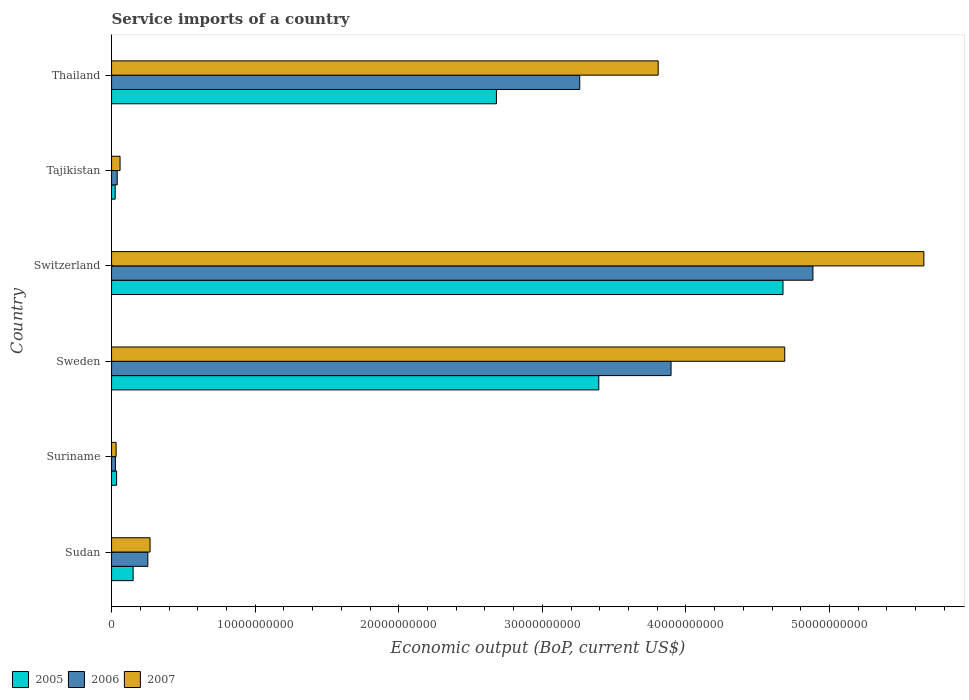Are the number of bars per tick equal to the number of legend labels?
Make the answer very short. Yes. How many bars are there on the 2nd tick from the bottom?
Make the answer very short. 3. What is the service imports in 2006 in Sweden?
Offer a terse response. 3.90e+1. Across all countries, what is the maximum service imports in 2007?
Your answer should be very brief. 5.66e+1. Across all countries, what is the minimum service imports in 2005?
Provide a short and direct response. 2.52e+08. In which country was the service imports in 2007 maximum?
Offer a terse response. Switzerland. In which country was the service imports in 2007 minimum?
Keep it short and to the point. Suriname. What is the total service imports in 2006 in the graph?
Give a very brief answer. 1.24e+11. What is the difference between the service imports in 2006 in Suriname and that in Thailand?
Make the answer very short. -3.23e+1. What is the difference between the service imports in 2006 in Sudan and the service imports in 2005 in Sweden?
Keep it short and to the point. -3.14e+1. What is the average service imports in 2006 per country?
Your answer should be very brief. 2.06e+1. What is the difference between the service imports in 2006 and service imports in 2007 in Sweden?
Ensure brevity in your answer.  -7.92e+09. What is the ratio of the service imports in 2006 in Sudan to that in Sweden?
Provide a succinct answer. 0.06. What is the difference between the highest and the second highest service imports in 2006?
Give a very brief answer. 9.88e+09. What is the difference between the highest and the lowest service imports in 2007?
Make the answer very short. 5.63e+1. Is the sum of the service imports in 2005 in Suriname and Tajikistan greater than the maximum service imports in 2006 across all countries?
Your answer should be compact. No. What does the 3rd bar from the bottom in Sudan represents?
Give a very brief answer. 2007. Is it the case that in every country, the sum of the service imports in 2005 and service imports in 2006 is greater than the service imports in 2007?
Make the answer very short. Yes. Are all the bars in the graph horizontal?
Offer a very short reply. Yes. How many countries are there in the graph?
Your answer should be very brief. 6. Does the graph contain any zero values?
Your answer should be compact. No. Where does the legend appear in the graph?
Your answer should be compact. Bottom left. How many legend labels are there?
Your answer should be very brief. 3. What is the title of the graph?
Your answer should be very brief. Service imports of a country. What is the label or title of the X-axis?
Your answer should be compact. Economic output (BoP, current US$). What is the Economic output (BoP, current US$) in 2005 in Sudan?
Make the answer very short. 1.50e+09. What is the Economic output (BoP, current US$) in 2006 in Sudan?
Your answer should be very brief. 2.53e+09. What is the Economic output (BoP, current US$) of 2007 in Sudan?
Ensure brevity in your answer.  2.68e+09. What is the Economic output (BoP, current US$) of 2005 in Suriname?
Provide a short and direct response. 3.52e+08. What is the Economic output (BoP, current US$) of 2006 in Suriname?
Offer a very short reply. 2.69e+08. What is the Economic output (BoP, current US$) in 2007 in Suriname?
Your response must be concise. 3.18e+08. What is the Economic output (BoP, current US$) of 2005 in Sweden?
Give a very brief answer. 3.39e+1. What is the Economic output (BoP, current US$) in 2006 in Sweden?
Offer a terse response. 3.90e+1. What is the Economic output (BoP, current US$) of 2007 in Sweden?
Your response must be concise. 4.69e+1. What is the Economic output (BoP, current US$) of 2005 in Switzerland?
Offer a terse response. 4.68e+1. What is the Economic output (BoP, current US$) in 2006 in Switzerland?
Offer a terse response. 4.88e+1. What is the Economic output (BoP, current US$) in 2007 in Switzerland?
Make the answer very short. 5.66e+1. What is the Economic output (BoP, current US$) in 2005 in Tajikistan?
Provide a short and direct response. 2.52e+08. What is the Economic output (BoP, current US$) in 2006 in Tajikistan?
Your response must be concise. 3.94e+08. What is the Economic output (BoP, current US$) of 2007 in Tajikistan?
Offer a terse response. 5.92e+08. What is the Economic output (BoP, current US$) of 2005 in Thailand?
Your response must be concise. 2.68e+1. What is the Economic output (BoP, current US$) of 2006 in Thailand?
Ensure brevity in your answer.  3.26e+1. What is the Economic output (BoP, current US$) in 2007 in Thailand?
Keep it short and to the point. 3.81e+1. Across all countries, what is the maximum Economic output (BoP, current US$) in 2005?
Give a very brief answer. 4.68e+1. Across all countries, what is the maximum Economic output (BoP, current US$) of 2006?
Provide a succinct answer. 4.88e+1. Across all countries, what is the maximum Economic output (BoP, current US$) in 2007?
Keep it short and to the point. 5.66e+1. Across all countries, what is the minimum Economic output (BoP, current US$) of 2005?
Your answer should be very brief. 2.52e+08. Across all countries, what is the minimum Economic output (BoP, current US$) of 2006?
Offer a terse response. 2.69e+08. Across all countries, what is the minimum Economic output (BoP, current US$) of 2007?
Ensure brevity in your answer.  3.18e+08. What is the total Economic output (BoP, current US$) of 2005 in the graph?
Provide a short and direct response. 1.10e+11. What is the total Economic output (BoP, current US$) in 2006 in the graph?
Offer a terse response. 1.24e+11. What is the total Economic output (BoP, current US$) of 2007 in the graph?
Offer a very short reply. 1.45e+11. What is the difference between the Economic output (BoP, current US$) in 2005 in Sudan and that in Suriname?
Give a very brief answer. 1.15e+09. What is the difference between the Economic output (BoP, current US$) in 2006 in Sudan and that in Suriname?
Your response must be concise. 2.26e+09. What is the difference between the Economic output (BoP, current US$) of 2007 in Sudan and that in Suriname?
Keep it short and to the point. 2.36e+09. What is the difference between the Economic output (BoP, current US$) in 2005 in Sudan and that in Sweden?
Make the answer very short. -3.24e+1. What is the difference between the Economic output (BoP, current US$) in 2006 in Sudan and that in Sweden?
Make the answer very short. -3.64e+1. What is the difference between the Economic output (BoP, current US$) of 2007 in Sudan and that in Sweden?
Keep it short and to the point. -4.42e+1. What is the difference between the Economic output (BoP, current US$) of 2005 in Sudan and that in Switzerland?
Ensure brevity in your answer.  -4.53e+1. What is the difference between the Economic output (BoP, current US$) of 2006 in Sudan and that in Switzerland?
Keep it short and to the point. -4.63e+1. What is the difference between the Economic output (BoP, current US$) in 2007 in Sudan and that in Switzerland?
Offer a very short reply. -5.39e+1. What is the difference between the Economic output (BoP, current US$) in 2005 in Sudan and that in Tajikistan?
Your response must be concise. 1.25e+09. What is the difference between the Economic output (BoP, current US$) in 2006 in Sudan and that in Tajikistan?
Give a very brief answer. 2.13e+09. What is the difference between the Economic output (BoP, current US$) of 2007 in Sudan and that in Tajikistan?
Offer a very short reply. 2.09e+09. What is the difference between the Economic output (BoP, current US$) of 2005 in Sudan and that in Thailand?
Your answer should be very brief. -2.53e+1. What is the difference between the Economic output (BoP, current US$) of 2006 in Sudan and that in Thailand?
Offer a very short reply. -3.01e+1. What is the difference between the Economic output (BoP, current US$) in 2007 in Sudan and that in Thailand?
Ensure brevity in your answer.  -3.54e+1. What is the difference between the Economic output (BoP, current US$) in 2005 in Suriname and that in Sweden?
Your answer should be compact. -3.36e+1. What is the difference between the Economic output (BoP, current US$) in 2006 in Suriname and that in Sweden?
Give a very brief answer. -3.87e+1. What is the difference between the Economic output (BoP, current US$) of 2007 in Suriname and that in Sweden?
Keep it short and to the point. -4.66e+1. What is the difference between the Economic output (BoP, current US$) of 2005 in Suriname and that in Switzerland?
Your response must be concise. -4.64e+1. What is the difference between the Economic output (BoP, current US$) in 2006 in Suriname and that in Switzerland?
Provide a short and direct response. -4.86e+1. What is the difference between the Economic output (BoP, current US$) of 2007 in Suriname and that in Switzerland?
Ensure brevity in your answer.  -5.63e+1. What is the difference between the Economic output (BoP, current US$) in 2005 in Suriname and that in Tajikistan?
Offer a terse response. 1.00e+08. What is the difference between the Economic output (BoP, current US$) of 2006 in Suriname and that in Tajikistan?
Offer a very short reply. -1.25e+08. What is the difference between the Economic output (BoP, current US$) in 2007 in Suriname and that in Tajikistan?
Offer a very short reply. -2.74e+08. What is the difference between the Economic output (BoP, current US$) in 2005 in Suriname and that in Thailand?
Keep it short and to the point. -2.65e+1. What is the difference between the Economic output (BoP, current US$) in 2006 in Suriname and that in Thailand?
Your answer should be very brief. -3.23e+1. What is the difference between the Economic output (BoP, current US$) of 2007 in Suriname and that in Thailand?
Provide a short and direct response. -3.77e+1. What is the difference between the Economic output (BoP, current US$) of 2005 in Sweden and that in Switzerland?
Your answer should be compact. -1.28e+1. What is the difference between the Economic output (BoP, current US$) in 2006 in Sweden and that in Switzerland?
Make the answer very short. -9.88e+09. What is the difference between the Economic output (BoP, current US$) of 2007 in Sweden and that in Switzerland?
Ensure brevity in your answer.  -9.69e+09. What is the difference between the Economic output (BoP, current US$) of 2005 in Sweden and that in Tajikistan?
Provide a short and direct response. 3.37e+1. What is the difference between the Economic output (BoP, current US$) in 2006 in Sweden and that in Tajikistan?
Your answer should be very brief. 3.86e+1. What is the difference between the Economic output (BoP, current US$) of 2007 in Sweden and that in Tajikistan?
Your answer should be very brief. 4.63e+1. What is the difference between the Economic output (BoP, current US$) of 2005 in Sweden and that in Thailand?
Provide a short and direct response. 7.13e+09. What is the difference between the Economic output (BoP, current US$) in 2006 in Sweden and that in Thailand?
Offer a terse response. 6.36e+09. What is the difference between the Economic output (BoP, current US$) in 2007 in Sweden and that in Thailand?
Your answer should be very brief. 8.81e+09. What is the difference between the Economic output (BoP, current US$) in 2005 in Switzerland and that in Tajikistan?
Make the answer very short. 4.65e+1. What is the difference between the Economic output (BoP, current US$) in 2006 in Switzerland and that in Tajikistan?
Make the answer very short. 4.84e+1. What is the difference between the Economic output (BoP, current US$) in 2007 in Switzerland and that in Tajikistan?
Your answer should be compact. 5.60e+1. What is the difference between the Economic output (BoP, current US$) in 2005 in Switzerland and that in Thailand?
Provide a succinct answer. 2.00e+1. What is the difference between the Economic output (BoP, current US$) of 2006 in Switzerland and that in Thailand?
Provide a succinct answer. 1.62e+1. What is the difference between the Economic output (BoP, current US$) in 2007 in Switzerland and that in Thailand?
Keep it short and to the point. 1.85e+1. What is the difference between the Economic output (BoP, current US$) in 2005 in Tajikistan and that in Thailand?
Provide a succinct answer. -2.66e+1. What is the difference between the Economic output (BoP, current US$) of 2006 in Tajikistan and that in Thailand?
Make the answer very short. -3.22e+1. What is the difference between the Economic output (BoP, current US$) of 2007 in Tajikistan and that in Thailand?
Provide a short and direct response. -3.75e+1. What is the difference between the Economic output (BoP, current US$) in 2005 in Sudan and the Economic output (BoP, current US$) in 2006 in Suriname?
Offer a very short reply. 1.23e+09. What is the difference between the Economic output (BoP, current US$) in 2005 in Sudan and the Economic output (BoP, current US$) in 2007 in Suriname?
Offer a terse response. 1.19e+09. What is the difference between the Economic output (BoP, current US$) of 2006 in Sudan and the Economic output (BoP, current US$) of 2007 in Suriname?
Make the answer very short. 2.21e+09. What is the difference between the Economic output (BoP, current US$) in 2005 in Sudan and the Economic output (BoP, current US$) in 2006 in Sweden?
Make the answer very short. -3.75e+1. What is the difference between the Economic output (BoP, current US$) in 2005 in Sudan and the Economic output (BoP, current US$) in 2007 in Sweden?
Ensure brevity in your answer.  -4.54e+1. What is the difference between the Economic output (BoP, current US$) in 2006 in Sudan and the Economic output (BoP, current US$) in 2007 in Sweden?
Keep it short and to the point. -4.44e+1. What is the difference between the Economic output (BoP, current US$) of 2005 in Sudan and the Economic output (BoP, current US$) of 2006 in Switzerland?
Your answer should be very brief. -4.73e+1. What is the difference between the Economic output (BoP, current US$) of 2005 in Sudan and the Economic output (BoP, current US$) of 2007 in Switzerland?
Provide a short and direct response. -5.51e+1. What is the difference between the Economic output (BoP, current US$) in 2006 in Sudan and the Economic output (BoP, current US$) in 2007 in Switzerland?
Your answer should be compact. -5.40e+1. What is the difference between the Economic output (BoP, current US$) in 2005 in Sudan and the Economic output (BoP, current US$) in 2006 in Tajikistan?
Provide a short and direct response. 1.11e+09. What is the difference between the Economic output (BoP, current US$) in 2005 in Sudan and the Economic output (BoP, current US$) in 2007 in Tajikistan?
Give a very brief answer. 9.11e+08. What is the difference between the Economic output (BoP, current US$) in 2006 in Sudan and the Economic output (BoP, current US$) in 2007 in Tajikistan?
Provide a short and direct response. 1.93e+09. What is the difference between the Economic output (BoP, current US$) of 2005 in Sudan and the Economic output (BoP, current US$) of 2006 in Thailand?
Offer a very short reply. -3.11e+1. What is the difference between the Economic output (BoP, current US$) in 2005 in Sudan and the Economic output (BoP, current US$) in 2007 in Thailand?
Your answer should be compact. -3.66e+1. What is the difference between the Economic output (BoP, current US$) in 2006 in Sudan and the Economic output (BoP, current US$) in 2007 in Thailand?
Give a very brief answer. -3.55e+1. What is the difference between the Economic output (BoP, current US$) in 2005 in Suriname and the Economic output (BoP, current US$) in 2006 in Sweden?
Your answer should be compact. -3.86e+1. What is the difference between the Economic output (BoP, current US$) of 2005 in Suriname and the Economic output (BoP, current US$) of 2007 in Sweden?
Offer a terse response. -4.65e+1. What is the difference between the Economic output (BoP, current US$) of 2006 in Suriname and the Economic output (BoP, current US$) of 2007 in Sweden?
Provide a short and direct response. -4.66e+1. What is the difference between the Economic output (BoP, current US$) in 2005 in Suriname and the Economic output (BoP, current US$) in 2006 in Switzerland?
Offer a very short reply. -4.85e+1. What is the difference between the Economic output (BoP, current US$) in 2005 in Suriname and the Economic output (BoP, current US$) in 2007 in Switzerland?
Your response must be concise. -5.62e+1. What is the difference between the Economic output (BoP, current US$) in 2006 in Suriname and the Economic output (BoP, current US$) in 2007 in Switzerland?
Offer a terse response. -5.63e+1. What is the difference between the Economic output (BoP, current US$) in 2005 in Suriname and the Economic output (BoP, current US$) in 2006 in Tajikistan?
Offer a very short reply. -4.27e+07. What is the difference between the Economic output (BoP, current US$) in 2005 in Suriname and the Economic output (BoP, current US$) in 2007 in Tajikistan?
Provide a succinct answer. -2.40e+08. What is the difference between the Economic output (BoP, current US$) in 2006 in Suriname and the Economic output (BoP, current US$) in 2007 in Tajikistan?
Your answer should be compact. -3.23e+08. What is the difference between the Economic output (BoP, current US$) of 2005 in Suriname and the Economic output (BoP, current US$) of 2006 in Thailand?
Your answer should be very brief. -3.23e+1. What is the difference between the Economic output (BoP, current US$) in 2005 in Suriname and the Economic output (BoP, current US$) in 2007 in Thailand?
Offer a very short reply. -3.77e+1. What is the difference between the Economic output (BoP, current US$) in 2006 in Suriname and the Economic output (BoP, current US$) in 2007 in Thailand?
Your answer should be compact. -3.78e+1. What is the difference between the Economic output (BoP, current US$) in 2005 in Sweden and the Economic output (BoP, current US$) in 2006 in Switzerland?
Offer a terse response. -1.49e+1. What is the difference between the Economic output (BoP, current US$) of 2005 in Sweden and the Economic output (BoP, current US$) of 2007 in Switzerland?
Offer a terse response. -2.26e+1. What is the difference between the Economic output (BoP, current US$) in 2006 in Sweden and the Economic output (BoP, current US$) in 2007 in Switzerland?
Offer a terse response. -1.76e+1. What is the difference between the Economic output (BoP, current US$) of 2005 in Sweden and the Economic output (BoP, current US$) of 2006 in Tajikistan?
Offer a terse response. 3.35e+1. What is the difference between the Economic output (BoP, current US$) in 2005 in Sweden and the Economic output (BoP, current US$) in 2007 in Tajikistan?
Your answer should be very brief. 3.33e+1. What is the difference between the Economic output (BoP, current US$) of 2006 in Sweden and the Economic output (BoP, current US$) of 2007 in Tajikistan?
Offer a very short reply. 3.84e+1. What is the difference between the Economic output (BoP, current US$) of 2005 in Sweden and the Economic output (BoP, current US$) of 2006 in Thailand?
Your answer should be very brief. 1.33e+09. What is the difference between the Economic output (BoP, current US$) of 2005 in Sweden and the Economic output (BoP, current US$) of 2007 in Thailand?
Keep it short and to the point. -4.13e+09. What is the difference between the Economic output (BoP, current US$) of 2006 in Sweden and the Economic output (BoP, current US$) of 2007 in Thailand?
Provide a short and direct response. 8.97e+08. What is the difference between the Economic output (BoP, current US$) in 2005 in Switzerland and the Economic output (BoP, current US$) in 2006 in Tajikistan?
Your answer should be very brief. 4.64e+1. What is the difference between the Economic output (BoP, current US$) in 2005 in Switzerland and the Economic output (BoP, current US$) in 2007 in Tajikistan?
Your answer should be compact. 4.62e+1. What is the difference between the Economic output (BoP, current US$) in 2006 in Switzerland and the Economic output (BoP, current US$) in 2007 in Tajikistan?
Your answer should be compact. 4.83e+1. What is the difference between the Economic output (BoP, current US$) of 2005 in Switzerland and the Economic output (BoP, current US$) of 2006 in Thailand?
Your response must be concise. 1.42e+1. What is the difference between the Economic output (BoP, current US$) of 2005 in Switzerland and the Economic output (BoP, current US$) of 2007 in Thailand?
Provide a short and direct response. 8.69e+09. What is the difference between the Economic output (BoP, current US$) in 2006 in Switzerland and the Economic output (BoP, current US$) in 2007 in Thailand?
Make the answer very short. 1.08e+1. What is the difference between the Economic output (BoP, current US$) in 2005 in Tajikistan and the Economic output (BoP, current US$) in 2006 in Thailand?
Give a very brief answer. -3.24e+1. What is the difference between the Economic output (BoP, current US$) of 2005 in Tajikistan and the Economic output (BoP, current US$) of 2007 in Thailand?
Offer a terse response. -3.78e+1. What is the difference between the Economic output (BoP, current US$) in 2006 in Tajikistan and the Economic output (BoP, current US$) in 2007 in Thailand?
Your answer should be very brief. -3.77e+1. What is the average Economic output (BoP, current US$) in 2005 per country?
Your answer should be very brief. 1.83e+1. What is the average Economic output (BoP, current US$) in 2006 per country?
Provide a succinct answer. 2.06e+1. What is the average Economic output (BoP, current US$) of 2007 per country?
Provide a short and direct response. 2.42e+1. What is the difference between the Economic output (BoP, current US$) of 2005 and Economic output (BoP, current US$) of 2006 in Sudan?
Provide a succinct answer. -1.02e+09. What is the difference between the Economic output (BoP, current US$) of 2005 and Economic output (BoP, current US$) of 2007 in Sudan?
Ensure brevity in your answer.  -1.18e+09. What is the difference between the Economic output (BoP, current US$) of 2006 and Economic output (BoP, current US$) of 2007 in Sudan?
Your answer should be very brief. -1.55e+08. What is the difference between the Economic output (BoP, current US$) of 2005 and Economic output (BoP, current US$) of 2006 in Suriname?
Keep it short and to the point. 8.25e+07. What is the difference between the Economic output (BoP, current US$) in 2005 and Economic output (BoP, current US$) in 2007 in Suriname?
Make the answer very short. 3.39e+07. What is the difference between the Economic output (BoP, current US$) of 2006 and Economic output (BoP, current US$) of 2007 in Suriname?
Offer a terse response. -4.86e+07. What is the difference between the Economic output (BoP, current US$) of 2005 and Economic output (BoP, current US$) of 2006 in Sweden?
Provide a succinct answer. -5.03e+09. What is the difference between the Economic output (BoP, current US$) of 2005 and Economic output (BoP, current US$) of 2007 in Sweden?
Offer a terse response. -1.29e+1. What is the difference between the Economic output (BoP, current US$) in 2006 and Economic output (BoP, current US$) in 2007 in Sweden?
Your answer should be compact. -7.92e+09. What is the difference between the Economic output (BoP, current US$) in 2005 and Economic output (BoP, current US$) in 2006 in Switzerland?
Your response must be concise. -2.08e+09. What is the difference between the Economic output (BoP, current US$) of 2005 and Economic output (BoP, current US$) of 2007 in Switzerland?
Give a very brief answer. -9.81e+09. What is the difference between the Economic output (BoP, current US$) in 2006 and Economic output (BoP, current US$) in 2007 in Switzerland?
Provide a short and direct response. -7.73e+09. What is the difference between the Economic output (BoP, current US$) of 2005 and Economic output (BoP, current US$) of 2006 in Tajikistan?
Keep it short and to the point. -1.43e+08. What is the difference between the Economic output (BoP, current US$) in 2005 and Economic output (BoP, current US$) in 2007 in Tajikistan?
Offer a terse response. -3.41e+08. What is the difference between the Economic output (BoP, current US$) in 2006 and Economic output (BoP, current US$) in 2007 in Tajikistan?
Make the answer very short. -1.98e+08. What is the difference between the Economic output (BoP, current US$) of 2005 and Economic output (BoP, current US$) of 2006 in Thailand?
Keep it short and to the point. -5.80e+09. What is the difference between the Economic output (BoP, current US$) of 2005 and Economic output (BoP, current US$) of 2007 in Thailand?
Your response must be concise. -1.13e+1. What is the difference between the Economic output (BoP, current US$) in 2006 and Economic output (BoP, current US$) in 2007 in Thailand?
Provide a succinct answer. -5.46e+09. What is the ratio of the Economic output (BoP, current US$) of 2005 in Sudan to that in Suriname?
Make the answer very short. 4.27. What is the ratio of the Economic output (BoP, current US$) in 2006 in Sudan to that in Suriname?
Keep it short and to the point. 9.38. What is the ratio of the Economic output (BoP, current US$) of 2007 in Sudan to that in Suriname?
Provide a short and direct response. 8.43. What is the ratio of the Economic output (BoP, current US$) of 2005 in Sudan to that in Sweden?
Your answer should be compact. 0.04. What is the ratio of the Economic output (BoP, current US$) in 2006 in Sudan to that in Sweden?
Offer a very short reply. 0.06. What is the ratio of the Economic output (BoP, current US$) in 2007 in Sudan to that in Sweden?
Your answer should be very brief. 0.06. What is the ratio of the Economic output (BoP, current US$) of 2005 in Sudan to that in Switzerland?
Give a very brief answer. 0.03. What is the ratio of the Economic output (BoP, current US$) in 2006 in Sudan to that in Switzerland?
Your response must be concise. 0.05. What is the ratio of the Economic output (BoP, current US$) of 2007 in Sudan to that in Switzerland?
Offer a very short reply. 0.05. What is the ratio of the Economic output (BoP, current US$) in 2005 in Sudan to that in Tajikistan?
Provide a succinct answer. 5.98. What is the ratio of the Economic output (BoP, current US$) of 2006 in Sudan to that in Tajikistan?
Give a very brief answer. 6.4. What is the ratio of the Economic output (BoP, current US$) in 2007 in Sudan to that in Tajikistan?
Provide a succinct answer. 4.53. What is the ratio of the Economic output (BoP, current US$) of 2005 in Sudan to that in Thailand?
Make the answer very short. 0.06. What is the ratio of the Economic output (BoP, current US$) in 2006 in Sudan to that in Thailand?
Ensure brevity in your answer.  0.08. What is the ratio of the Economic output (BoP, current US$) in 2007 in Sudan to that in Thailand?
Ensure brevity in your answer.  0.07. What is the ratio of the Economic output (BoP, current US$) in 2005 in Suriname to that in Sweden?
Provide a succinct answer. 0.01. What is the ratio of the Economic output (BoP, current US$) in 2006 in Suriname to that in Sweden?
Provide a succinct answer. 0.01. What is the ratio of the Economic output (BoP, current US$) of 2007 in Suriname to that in Sweden?
Your response must be concise. 0.01. What is the ratio of the Economic output (BoP, current US$) in 2005 in Suriname to that in Switzerland?
Ensure brevity in your answer.  0.01. What is the ratio of the Economic output (BoP, current US$) of 2006 in Suriname to that in Switzerland?
Your response must be concise. 0.01. What is the ratio of the Economic output (BoP, current US$) of 2007 in Suriname to that in Switzerland?
Your response must be concise. 0.01. What is the ratio of the Economic output (BoP, current US$) in 2005 in Suriname to that in Tajikistan?
Your answer should be very brief. 1.4. What is the ratio of the Economic output (BoP, current US$) of 2006 in Suriname to that in Tajikistan?
Offer a terse response. 0.68. What is the ratio of the Economic output (BoP, current US$) in 2007 in Suriname to that in Tajikistan?
Give a very brief answer. 0.54. What is the ratio of the Economic output (BoP, current US$) in 2005 in Suriname to that in Thailand?
Make the answer very short. 0.01. What is the ratio of the Economic output (BoP, current US$) of 2006 in Suriname to that in Thailand?
Make the answer very short. 0.01. What is the ratio of the Economic output (BoP, current US$) of 2007 in Suriname to that in Thailand?
Give a very brief answer. 0.01. What is the ratio of the Economic output (BoP, current US$) in 2005 in Sweden to that in Switzerland?
Your answer should be very brief. 0.73. What is the ratio of the Economic output (BoP, current US$) in 2006 in Sweden to that in Switzerland?
Your answer should be very brief. 0.8. What is the ratio of the Economic output (BoP, current US$) in 2007 in Sweden to that in Switzerland?
Your response must be concise. 0.83. What is the ratio of the Economic output (BoP, current US$) of 2005 in Sweden to that in Tajikistan?
Your response must be concise. 134.91. What is the ratio of the Economic output (BoP, current US$) in 2006 in Sweden to that in Tajikistan?
Keep it short and to the point. 98.77. What is the ratio of the Economic output (BoP, current US$) of 2007 in Sweden to that in Tajikistan?
Your response must be concise. 79.18. What is the ratio of the Economic output (BoP, current US$) in 2005 in Sweden to that in Thailand?
Make the answer very short. 1.27. What is the ratio of the Economic output (BoP, current US$) of 2006 in Sweden to that in Thailand?
Provide a short and direct response. 1.2. What is the ratio of the Economic output (BoP, current US$) in 2007 in Sweden to that in Thailand?
Make the answer very short. 1.23. What is the ratio of the Economic output (BoP, current US$) in 2005 in Switzerland to that in Tajikistan?
Your answer should be very brief. 185.91. What is the ratio of the Economic output (BoP, current US$) in 2006 in Switzerland to that in Tajikistan?
Ensure brevity in your answer.  123.81. What is the ratio of the Economic output (BoP, current US$) of 2007 in Switzerland to that in Tajikistan?
Give a very brief answer. 95.55. What is the ratio of the Economic output (BoP, current US$) of 2005 in Switzerland to that in Thailand?
Give a very brief answer. 1.74. What is the ratio of the Economic output (BoP, current US$) in 2006 in Switzerland to that in Thailand?
Give a very brief answer. 1.5. What is the ratio of the Economic output (BoP, current US$) in 2007 in Switzerland to that in Thailand?
Your response must be concise. 1.49. What is the ratio of the Economic output (BoP, current US$) in 2005 in Tajikistan to that in Thailand?
Your answer should be very brief. 0.01. What is the ratio of the Economic output (BoP, current US$) of 2006 in Tajikistan to that in Thailand?
Provide a succinct answer. 0.01. What is the ratio of the Economic output (BoP, current US$) of 2007 in Tajikistan to that in Thailand?
Offer a very short reply. 0.02. What is the difference between the highest and the second highest Economic output (BoP, current US$) in 2005?
Your answer should be very brief. 1.28e+1. What is the difference between the highest and the second highest Economic output (BoP, current US$) of 2006?
Give a very brief answer. 9.88e+09. What is the difference between the highest and the second highest Economic output (BoP, current US$) of 2007?
Give a very brief answer. 9.69e+09. What is the difference between the highest and the lowest Economic output (BoP, current US$) in 2005?
Keep it short and to the point. 4.65e+1. What is the difference between the highest and the lowest Economic output (BoP, current US$) in 2006?
Your answer should be very brief. 4.86e+1. What is the difference between the highest and the lowest Economic output (BoP, current US$) of 2007?
Your answer should be very brief. 5.63e+1. 